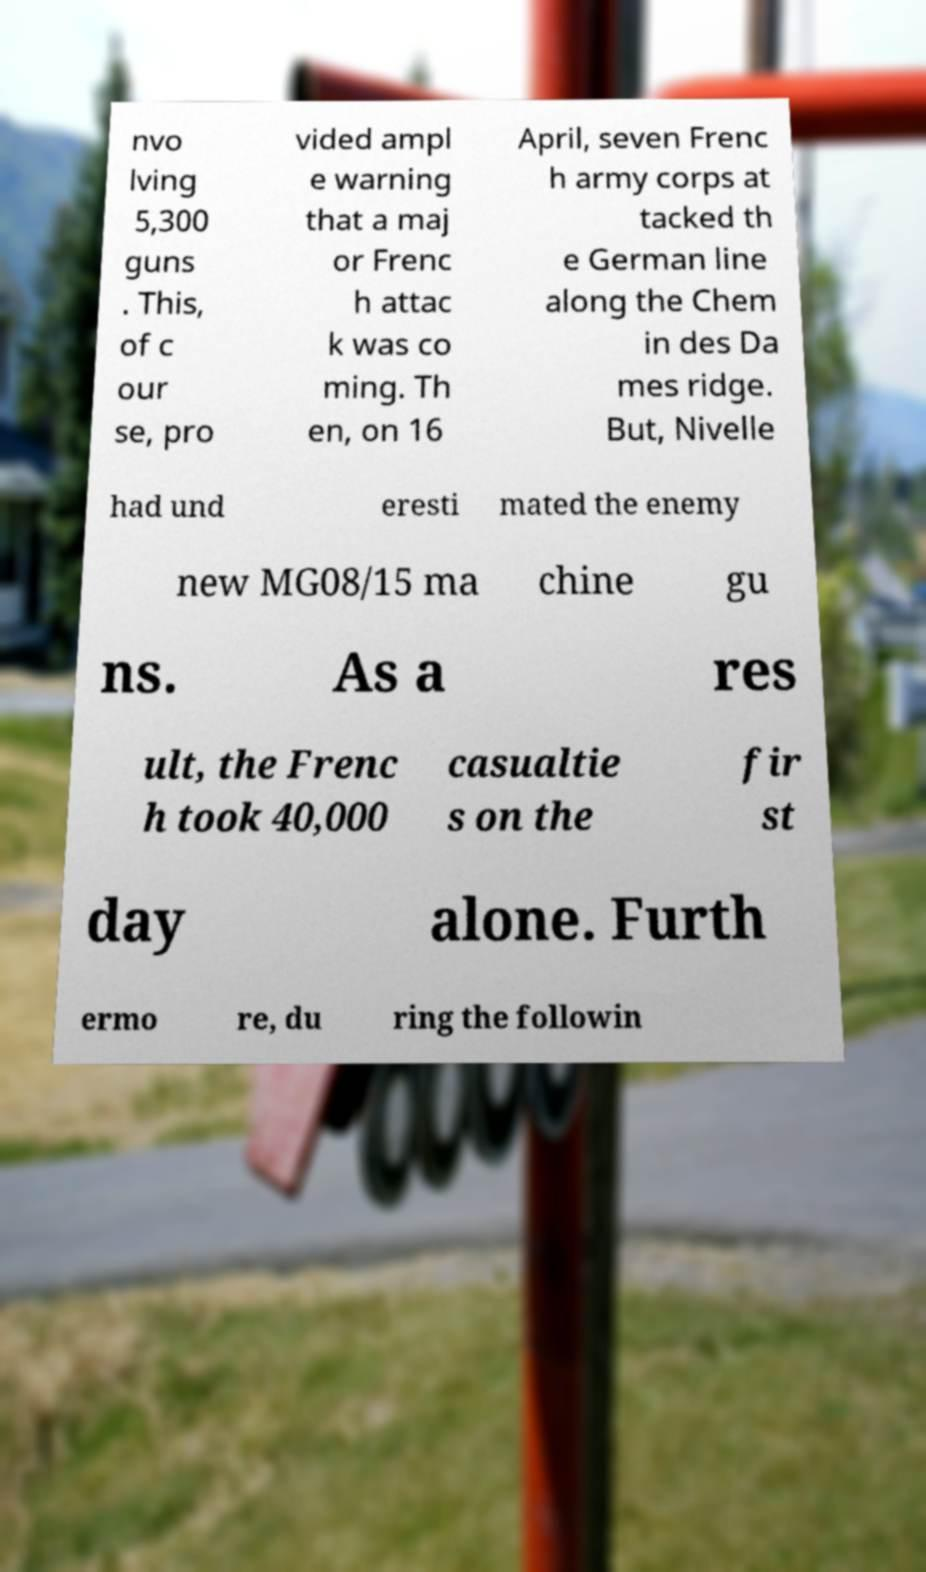Can you read and provide the text displayed in the image?This photo seems to have some interesting text. Can you extract and type it out for me? nvo lving 5,300 guns . This, of c our se, pro vided ampl e warning that a maj or Frenc h attac k was co ming. Th en, on 16 April, seven Frenc h army corps at tacked th e German line along the Chem in des Da mes ridge. But, Nivelle had und eresti mated the enemy new MG08/15 ma chine gu ns. As a res ult, the Frenc h took 40,000 casualtie s on the fir st day alone. Furth ermo re, du ring the followin 